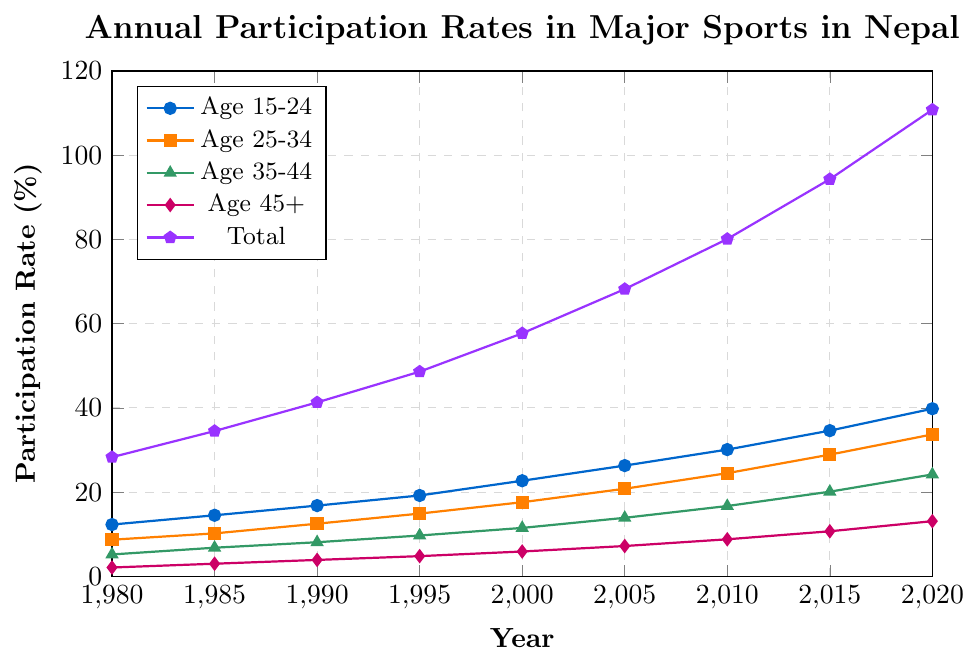What trend can you observe in the participation rates for the age group 15-24 from 1980 to 2020? The participation rates for the age group 15-24 show a steady upward trend from 12.3% in 1980 to 39.8% in 2020.
Answer: Steady increase Which age group experienced the highest increase in participation rates from 1980 to 2020? To determine the highest increase, subtract the participation rate in 1980 from that in 2020 for each age group. The increases are: 15-24 (39.8 - 12.3 = 27.5), 25-34 (33.7 - 8.7 = 25.0), 35-44 (24.2 - 5.2 = 19.0), 45+ (13.1 - 2.1 = 11.0), and the Total (110.8 - 28.3 = 82.5). The age group 15-24 experienced the highest increase (27.5%).
Answer: Age 15-24 By how much did the overall participation rate change from 2000 to 2020? The overall participation rate in 2000 was 57.7% and in 2020 it was 110.8%. The change is 110.8 - 57.7 = 53.1%.
Answer: 53.1% In which year did the age group 45+ surpass 10% participation for the first time, and what was the specific percentage? By examining the data points for age group 45+, we see the participation surpasses 10% for the first time in 2015, with a rate of 10.7%.
Answer: 2015, 10.7% Compare the participation rates between age groups 15-24 and 35-44 in 2020. Which group had a higher rate, and by how much? In 2020, the age group 15-24 had a participation rate of 39.8%, and the age group 35-44 had a rate of 24.2%. The difference is 39.8% - 24.2% = 15.6%. Age group 15-24 had a higher rate by 15.6%.
Answer: Age 15-24, by 15.6% What is the average rate of participation across all age groups in the year 2015? To find the average rate in 2015, sum the participation rates for all age groups (34.6 + 28.9 + 20.1 + 10.7 = 94.3) and divide by the number of age groups (4). The average rate is 94.3 / 4 = 23.575%.
Answer: 23.575% Was there any year between 1980 and 2020 where the rates for Age 25-34 and Age 35-44 were equal? By checking the dataset, there is no year where the participation rates for Age 25-34 and Age 35-44 were equal.
Answer: No Identify the age group with the lowest participation rate in 1980 and provide the rate. Observing the participation rates in 1980, Age 45+ had the lowest rate at 2.1%.
Answer: Age 45+, 2.1% Between 1980 and 2000, which single age group saw the greatest percentage increase in participation? To find the greatest percentage increase, compute the percentage increase for each age group: Age 15-24 ((22.7 - 12.3)/12.3)*100 = 84.6%, Age 25-34 ((17.6 - 8.7)/8.7)*100 = 102.3%, Age 35-44 ((11.5 - 5.2)/5.2)*100 = 121.2%, Age 45+ ((5.9 - 2.1)/2.1)*100 = 180.95%. Age 45+ saw the greatest percentage increase of 180.95%.
Answer: Age 45+, 180.95% 